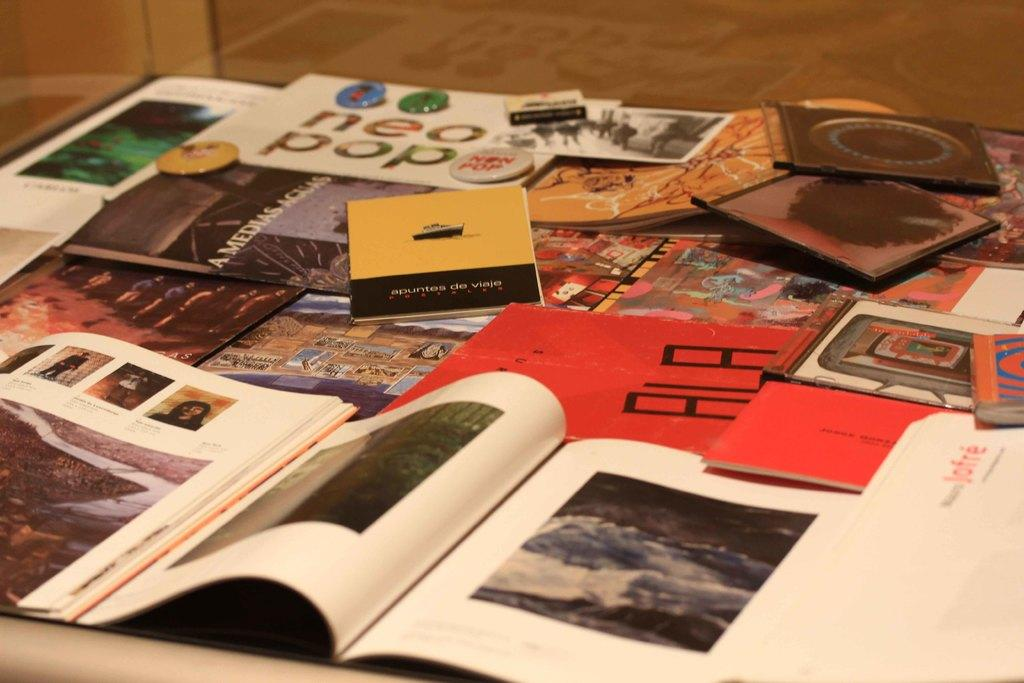Provide a one-sentence caption for the provided image. An interesting array of various reading materials including magazines. 